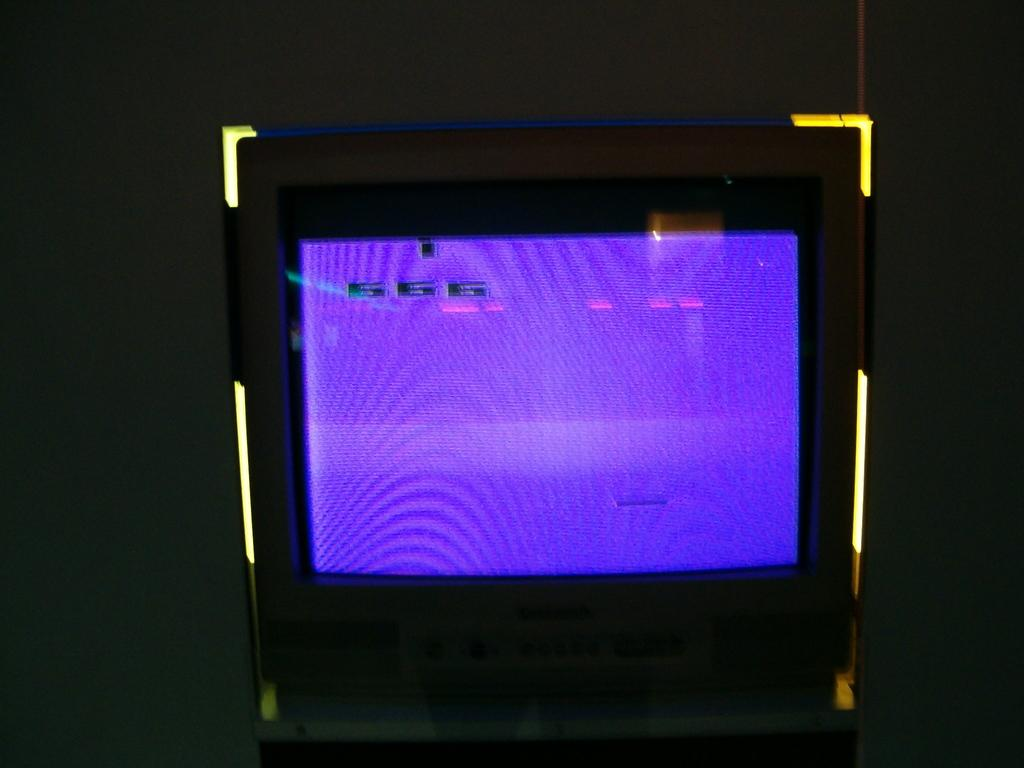<image>
Present a compact description of the photo's key features. The number 666 is displayed on a video screen that's colored light purple. 